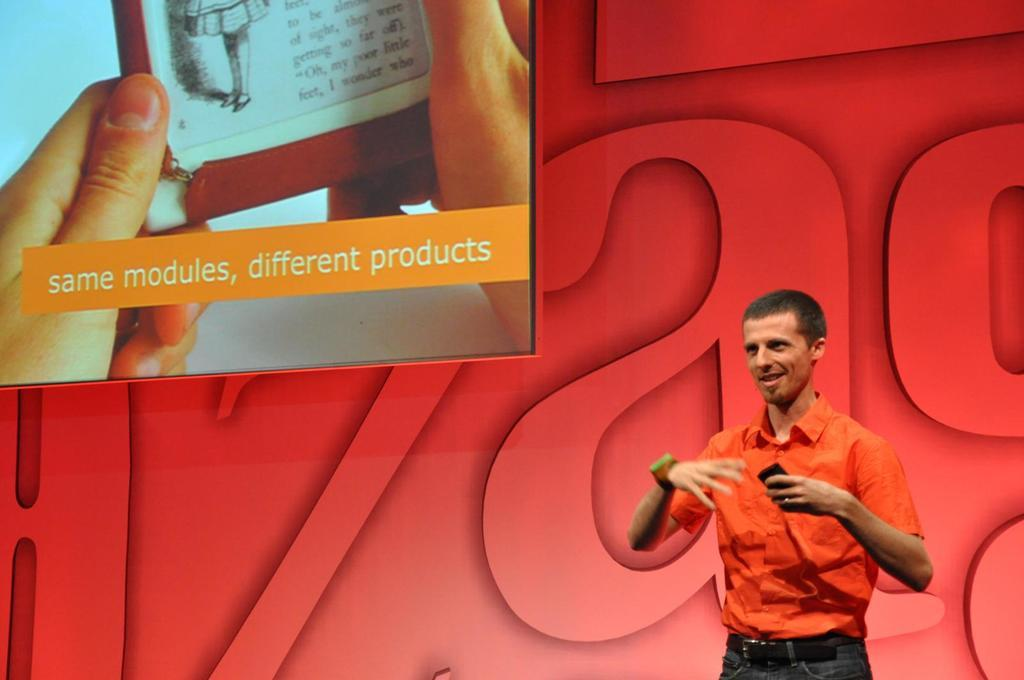<image>
Give a short and clear explanation of the subsequent image. a man standing beside a projection screen that says 'same modules, different products' 